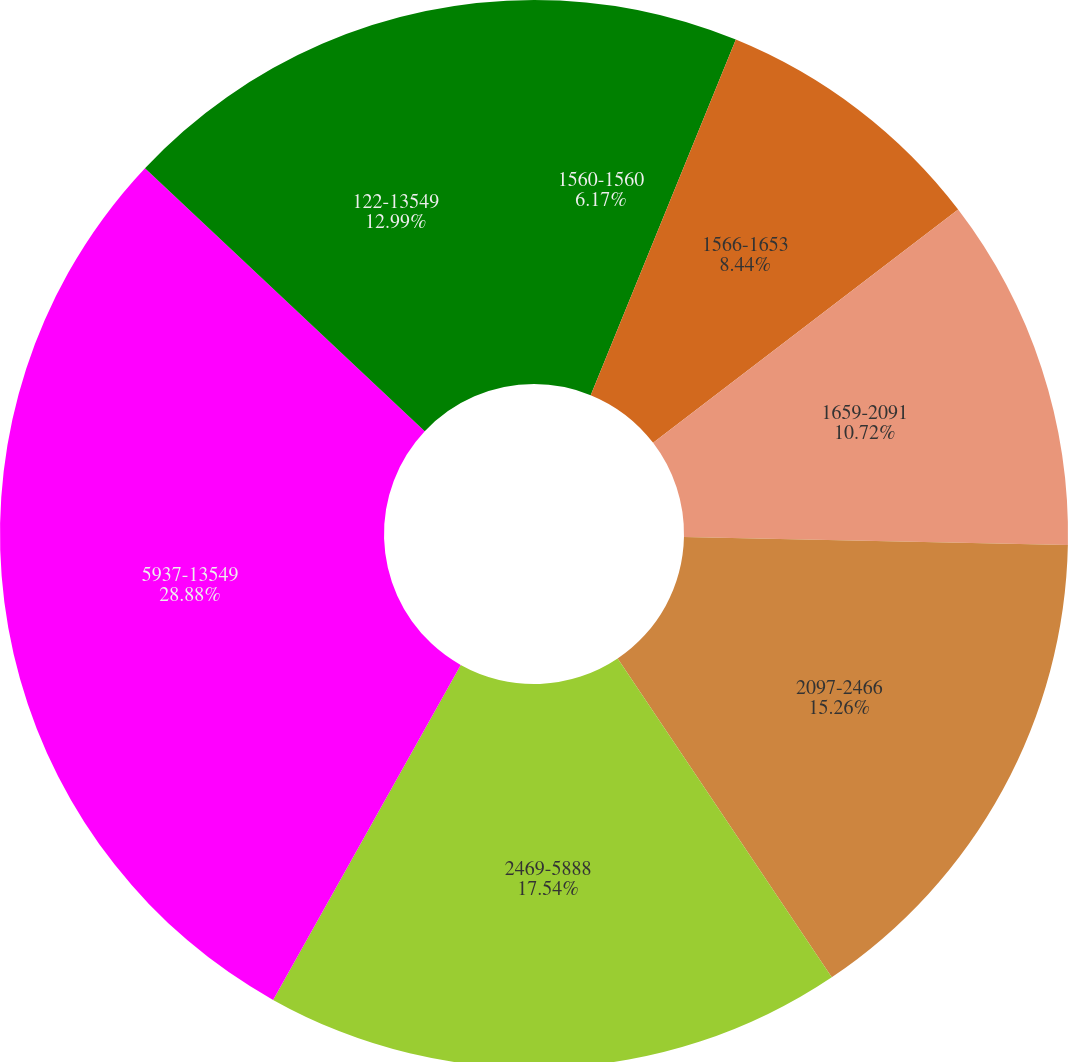<chart> <loc_0><loc_0><loc_500><loc_500><pie_chart><fcel>1560-1560<fcel>1566-1653<fcel>1659-2091<fcel>2097-2466<fcel>2469-5888<fcel>5937-13549<fcel>122-13549<nl><fcel>6.17%<fcel>8.44%<fcel>10.72%<fcel>15.26%<fcel>17.54%<fcel>28.89%<fcel>12.99%<nl></chart> 